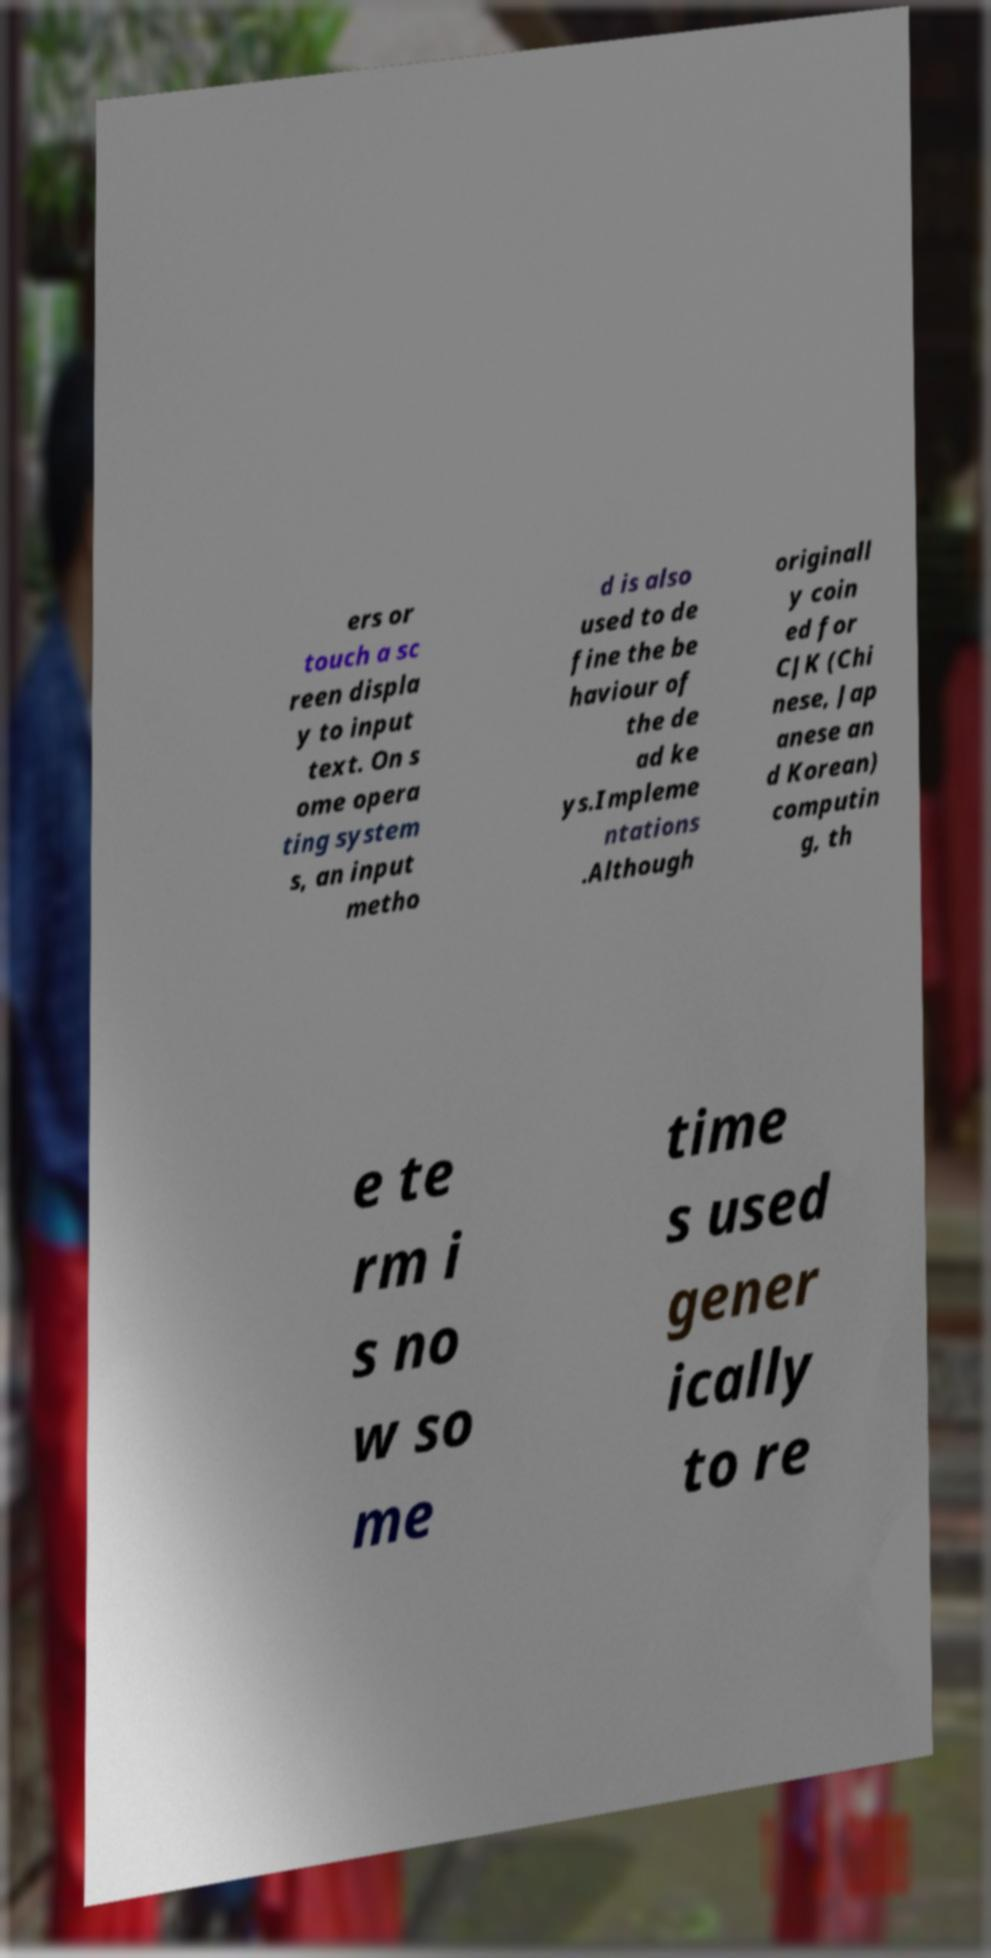I need the written content from this picture converted into text. Can you do that? ers or touch a sc reen displa y to input text. On s ome opera ting system s, an input metho d is also used to de fine the be haviour of the de ad ke ys.Impleme ntations .Although originall y coin ed for CJK (Chi nese, Jap anese an d Korean) computin g, th e te rm i s no w so me time s used gener ically to re 